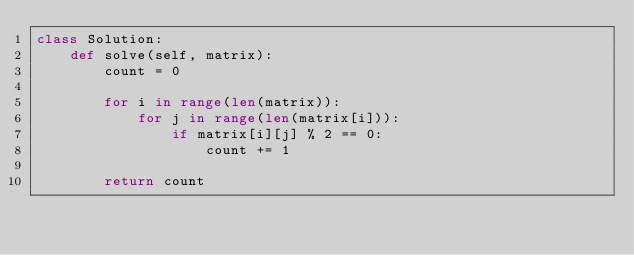<code> <loc_0><loc_0><loc_500><loc_500><_Python_>class Solution:
    def solve(self, matrix):
        count = 0

        for i in range(len(matrix)):
            for j in range(len(matrix[i])):
                if matrix[i][j] % 2 == 0:
                    count += 1

        return count
</code> 